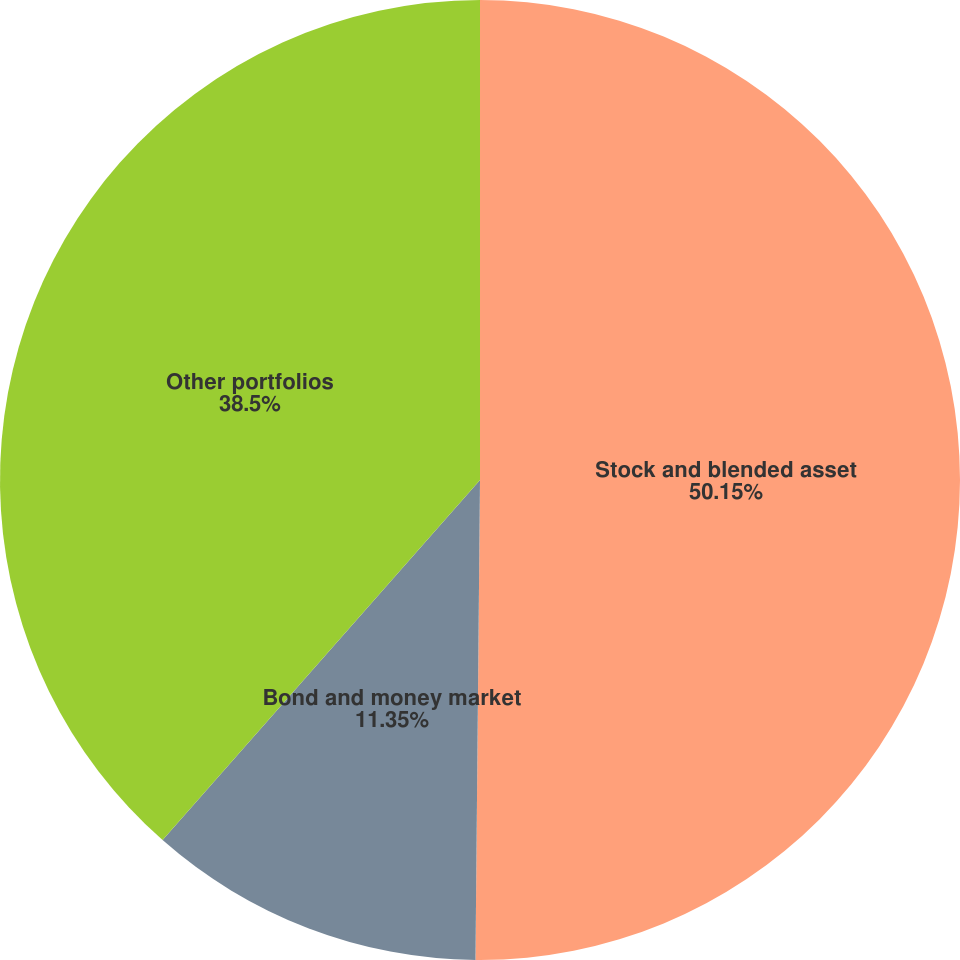<chart> <loc_0><loc_0><loc_500><loc_500><pie_chart><fcel>Stock and blended asset<fcel>Bond and money market<fcel>Other portfolios<nl><fcel>50.15%<fcel>11.35%<fcel>38.5%<nl></chart> 